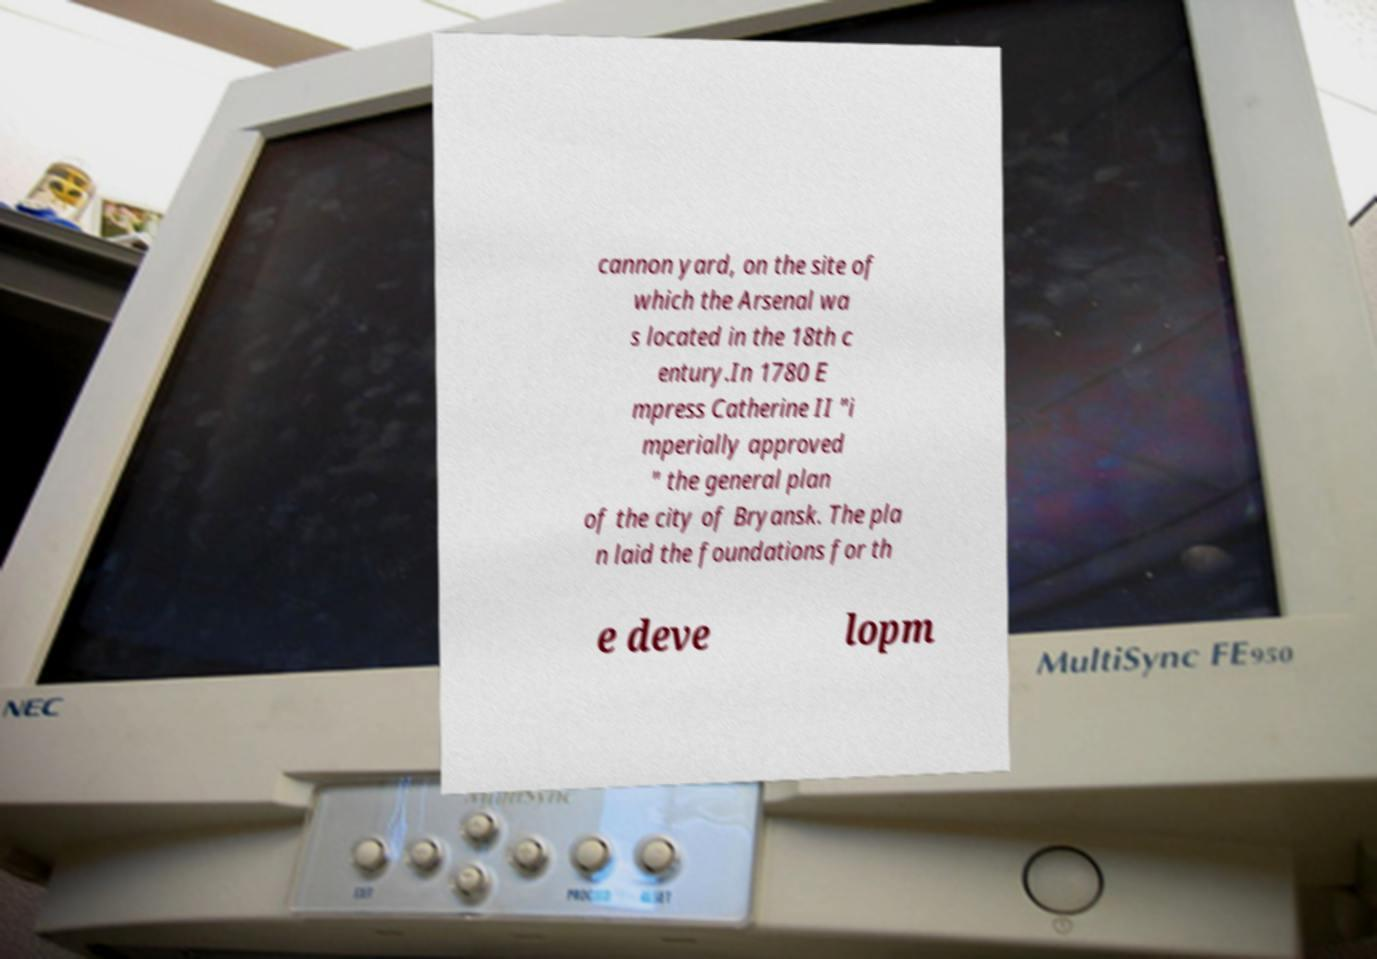There's text embedded in this image that I need extracted. Can you transcribe it verbatim? cannon yard, on the site of which the Arsenal wa s located in the 18th c entury.In 1780 E mpress Catherine II "i mperially approved " the general plan of the city of Bryansk. The pla n laid the foundations for th e deve lopm 